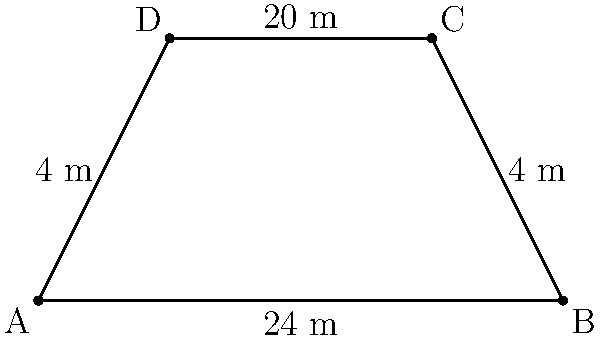As part of a sociological study on urban planning and community design, you're analyzing the layout of a neighborhood block. The block is represented as a trapezoid, as shown in the figure. If the parallel sides of the trapezoid measure 24 m and 20 m, and the non-parallel sides are both 4 m, what is the perimeter of this neighborhood block? To find the perimeter of the trapezoid-shaped neighborhood block, we need to sum up the lengths of all four sides. Let's approach this step-by-step:

1) We are given that:
   - The bottom parallel side (AB) measures 24 m
   - The top parallel side (DC) measures 20 m
   - Both non-parallel sides (AD and BC) measure 4 m each

2) The perimeter is the sum of all sides:
   $$ \text{Perimeter} = AB + BC + CD + DA $$

3) Substituting the known values:
   $$ \text{Perimeter} = 24 \text{ m} + 4 \text{ m} + 20 \text{ m} + 4 \text{ m} $$

4) Adding these values:
   $$ \text{Perimeter} = 52 \text{ m} $$

Therefore, the perimeter of the neighborhood block is 52 meters.
Answer: 52 m 